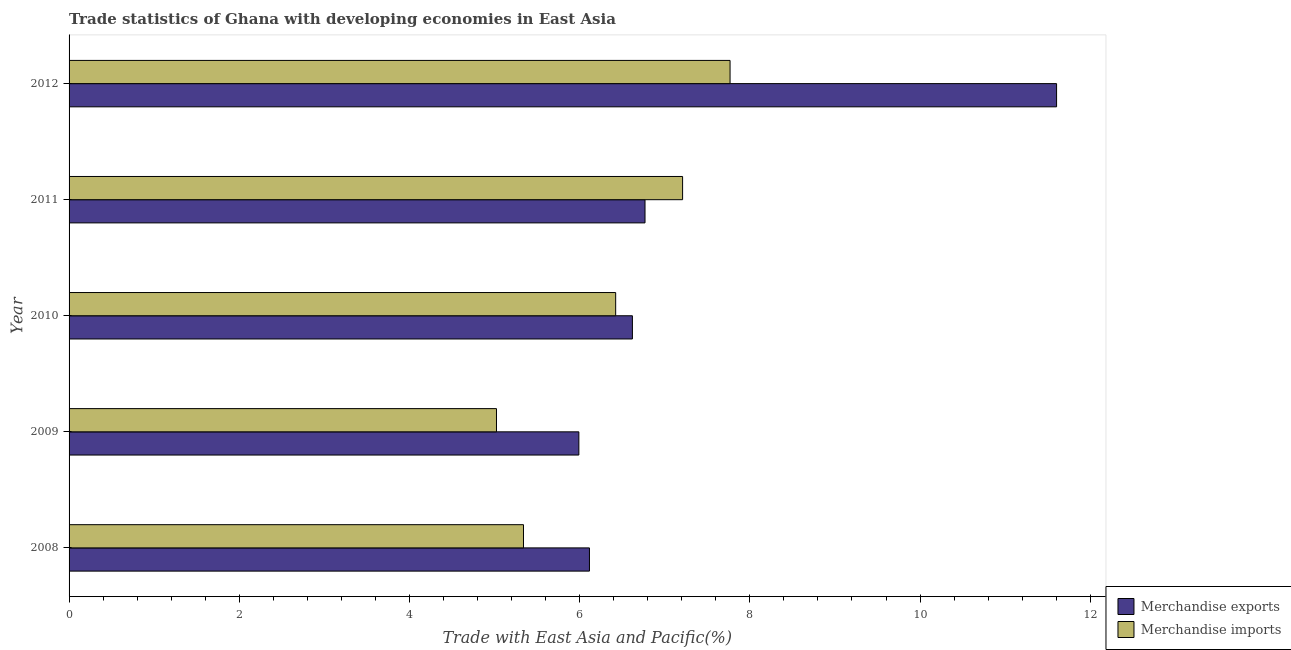How many different coloured bars are there?
Your answer should be very brief. 2. How many groups of bars are there?
Offer a terse response. 5. How many bars are there on the 3rd tick from the top?
Offer a terse response. 2. What is the merchandise exports in 2011?
Give a very brief answer. 6.77. Across all years, what is the maximum merchandise exports?
Make the answer very short. 11.6. Across all years, what is the minimum merchandise exports?
Make the answer very short. 5.99. In which year was the merchandise exports maximum?
Ensure brevity in your answer.  2012. In which year was the merchandise imports minimum?
Provide a succinct answer. 2009. What is the total merchandise imports in the graph?
Provide a short and direct response. 31.76. What is the difference between the merchandise imports in 2009 and that in 2010?
Offer a terse response. -1.4. What is the difference between the merchandise imports in 2010 and the merchandise exports in 2012?
Offer a terse response. -5.18. What is the average merchandise imports per year?
Keep it short and to the point. 6.35. In the year 2012, what is the difference between the merchandise imports and merchandise exports?
Your answer should be compact. -3.84. What is the ratio of the merchandise exports in 2009 to that in 2010?
Offer a terse response. 0.91. Is the merchandise imports in 2008 less than that in 2011?
Ensure brevity in your answer.  Yes. Is the difference between the merchandise exports in 2008 and 2011 greater than the difference between the merchandise imports in 2008 and 2011?
Make the answer very short. Yes. What is the difference between the highest and the second highest merchandise imports?
Your answer should be compact. 0.56. What is the difference between the highest and the lowest merchandise exports?
Ensure brevity in your answer.  5.61. What is the difference between two consecutive major ticks on the X-axis?
Provide a short and direct response. 2. Are the values on the major ticks of X-axis written in scientific E-notation?
Make the answer very short. No. How many legend labels are there?
Your answer should be compact. 2. How are the legend labels stacked?
Keep it short and to the point. Vertical. What is the title of the graph?
Give a very brief answer. Trade statistics of Ghana with developing economies in East Asia. Does "Methane emissions" appear as one of the legend labels in the graph?
Provide a short and direct response. No. What is the label or title of the X-axis?
Keep it short and to the point. Trade with East Asia and Pacific(%). What is the label or title of the Y-axis?
Keep it short and to the point. Year. What is the Trade with East Asia and Pacific(%) of Merchandise exports in 2008?
Offer a very short reply. 6.12. What is the Trade with East Asia and Pacific(%) in Merchandise imports in 2008?
Keep it short and to the point. 5.34. What is the Trade with East Asia and Pacific(%) of Merchandise exports in 2009?
Keep it short and to the point. 5.99. What is the Trade with East Asia and Pacific(%) of Merchandise imports in 2009?
Make the answer very short. 5.02. What is the Trade with East Asia and Pacific(%) of Merchandise exports in 2010?
Your response must be concise. 6.62. What is the Trade with East Asia and Pacific(%) of Merchandise imports in 2010?
Your response must be concise. 6.42. What is the Trade with East Asia and Pacific(%) in Merchandise exports in 2011?
Offer a terse response. 6.77. What is the Trade with East Asia and Pacific(%) in Merchandise imports in 2011?
Your answer should be compact. 7.21. What is the Trade with East Asia and Pacific(%) in Merchandise exports in 2012?
Offer a very short reply. 11.6. What is the Trade with East Asia and Pacific(%) in Merchandise imports in 2012?
Your answer should be very brief. 7.77. Across all years, what is the maximum Trade with East Asia and Pacific(%) of Merchandise exports?
Give a very brief answer. 11.6. Across all years, what is the maximum Trade with East Asia and Pacific(%) in Merchandise imports?
Make the answer very short. 7.77. Across all years, what is the minimum Trade with East Asia and Pacific(%) in Merchandise exports?
Offer a terse response. 5.99. Across all years, what is the minimum Trade with East Asia and Pacific(%) of Merchandise imports?
Provide a succinct answer. 5.02. What is the total Trade with East Asia and Pacific(%) of Merchandise exports in the graph?
Offer a terse response. 37.1. What is the total Trade with East Asia and Pacific(%) in Merchandise imports in the graph?
Provide a succinct answer. 31.76. What is the difference between the Trade with East Asia and Pacific(%) of Merchandise exports in 2008 and that in 2009?
Ensure brevity in your answer.  0.12. What is the difference between the Trade with East Asia and Pacific(%) of Merchandise imports in 2008 and that in 2009?
Your answer should be compact. 0.32. What is the difference between the Trade with East Asia and Pacific(%) in Merchandise exports in 2008 and that in 2010?
Offer a terse response. -0.5. What is the difference between the Trade with East Asia and Pacific(%) in Merchandise imports in 2008 and that in 2010?
Provide a succinct answer. -1.08. What is the difference between the Trade with East Asia and Pacific(%) of Merchandise exports in 2008 and that in 2011?
Give a very brief answer. -0.65. What is the difference between the Trade with East Asia and Pacific(%) of Merchandise imports in 2008 and that in 2011?
Offer a terse response. -1.87. What is the difference between the Trade with East Asia and Pacific(%) of Merchandise exports in 2008 and that in 2012?
Your response must be concise. -5.49. What is the difference between the Trade with East Asia and Pacific(%) in Merchandise imports in 2008 and that in 2012?
Make the answer very short. -2.43. What is the difference between the Trade with East Asia and Pacific(%) of Merchandise exports in 2009 and that in 2010?
Keep it short and to the point. -0.63. What is the difference between the Trade with East Asia and Pacific(%) of Merchandise imports in 2009 and that in 2010?
Ensure brevity in your answer.  -1.4. What is the difference between the Trade with East Asia and Pacific(%) of Merchandise exports in 2009 and that in 2011?
Provide a succinct answer. -0.78. What is the difference between the Trade with East Asia and Pacific(%) of Merchandise imports in 2009 and that in 2011?
Provide a succinct answer. -2.19. What is the difference between the Trade with East Asia and Pacific(%) of Merchandise exports in 2009 and that in 2012?
Provide a short and direct response. -5.61. What is the difference between the Trade with East Asia and Pacific(%) in Merchandise imports in 2009 and that in 2012?
Ensure brevity in your answer.  -2.74. What is the difference between the Trade with East Asia and Pacific(%) in Merchandise exports in 2010 and that in 2011?
Ensure brevity in your answer.  -0.15. What is the difference between the Trade with East Asia and Pacific(%) in Merchandise imports in 2010 and that in 2011?
Ensure brevity in your answer.  -0.79. What is the difference between the Trade with East Asia and Pacific(%) of Merchandise exports in 2010 and that in 2012?
Your answer should be very brief. -4.98. What is the difference between the Trade with East Asia and Pacific(%) in Merchandise imports in 2010 and that in 2012?
Make the answer very short. -1.34. What is the difference between the Trade with East Asia and Pacific(%) in Merchandise exports in 2011 and that in 2012?
Offer a very short reply. -4.84. What is the difference between the Trade with East Asia and Pacific(%) of Merchandise imports in 2011 and that in 2012?
Ensure brevity in your answer.  -0.56. What is the difference between the Trade with East Asia and Pacific(%) of Merchandise exports in 2008 and the Trade with East Asia and Pacific(%) of Merchandise imports in 2009?
Provide a short and direct response. 1.09. What is the difference between the Trade with East Asia and Pacific(%) of Merchandise exports in 2008 and the Trade with East Asia and Pacific(%) of Merchandise imports in 2010?
Your answer should be very brief. -0.31. What is the difference between the Trade with East Asia and Pacific(%) of Merchandise exports in 2008 and the Trade with East Asia and Pacific(%) of Merchandise imports in 2011?
Offer a very short reply. -1.09. What is the difference between the Trade with East Asia and Pacific(%) of Merchandise exports in 2008 and the Trade with East Asia and Pacific(%) of Merchandise imports in 2012?
Make the answer very short. -1.65. What is the difference between the Trade with East Asia and Pacific(%) of Merchandise exports in 2009 and the Trade with East Asia and Pacific(%) of Merchandise imports in 2010?
Offer a terse response. -0.43. What is the difference between the Trade with East Asia and Pacific(%) of Merchandise exports in 2009 and the Trade with East Asia and Pacific(%) of Merchandise imports in 2011?
Offer a terse response. -1.22. What is the difference between the Trade with East Asia and Pacific(%) in Merchandise exports in 2009 and the Trade with East Asia and Pacific(%) in Merchandise imports in 2012?
Your answer should be compact. -1.78. What is the difference between the Trade with East Asia and Pacific(%) in Merchandise exports in 2010 and the Trade with East Asia and Pacific(%) in Merchandise imports in 2011?
Ensure brevity in your answer.  -0.59. What is the difference between the Trade with East Asia and Pacific(%) of Merchandise exports in 2010 and the Trade with East Asia and Pacific(%) of Merchandise imports in 2012?
Offer a very short reply. -1.15. What is the difference between the Trade with East Asia and Pacific(%) of Merchandise exports in 2011 and the Trade with East Asia and Pacific(%) of Merchandise imports in 2012?
Your response must be concise. -1. What is the average Trade with East Asia and Pacific(%) in Merchandise exports per year?
Your answer should be compact. 7.42. What is the average Trade with East Asia and Pacific(%) of Merchandise imports per year?
Offer a very short reply. 6.35. In the year 2008, what is the difference between the Trade with East Asia and Pacific(%) in Merchandise exports and Trade with East Asia and Pacific(%) in Merchandise imports?
Your answer should be very brief. 0.78. In the year 2009, what is the difference between the Trade with East Asia and Pacific(%) in Merchandise exports and Trade with East Asia and Pacific(%) in Merchandise imports?
Ensure brevity in your answer.  0.97. In the year 2010, what is the difference between the Trade with East Asia and Pacific(%) in Merchandise exports and Trade with East Asia and Pacific(%) in Merchandise imports?
Give a very brief answer. 0.2. In the year 2011, what is the difference between the Trade with East Asia and Pacific(%) of Merchandise exports and Trade with East Asia and Pacific(%) of Merchandise imports?
Ensure brevity in your answer.  -0.44. In the year 2012, what is the difference between the Trade with East Asia and Pacific(%) of Merchandise exports and Trade with East Asia and Pacific(%) of Merchandise imports?
Give a very brief answer. 3.84. What is the ratio of the Trade with East Asia and Pacific(%) of Merchandise exports in 2008 to that in 2009?
Your answer should be very brief. 1.02. What is the ratio of the Trade with East Asia and Pacific(%) of Merchandise imports in 2008 to that in 2009?
Make the answer very short. 1.06. What is the ratio of the Trade with East Asia and Pacific(%) in Merchandise exports in 2008 to that in 2010?
Provide a succinct answer. 0.92. What is the ratio of the Trade with East Asia and Pacific(%) in Merchandise imports in 2008 to that in 2010?
Provide a succinct answer. 0.83. What is the ratio of the Trade with East Asia and Pacific(%) in Merchandise exports in 2008 to that in 2011?
Ensure brevity in your answer.  0.9. What is the ratio of the Trade with East Asia and Pacific(%) of Merchandise imports in 2008 to that in 2011?
Give a very brief answer. 0.74. What is the ratio of the Trade with East Asia and Pacific(%) of Merchandise exports in 2008 to that in 2012?
Your answer should be compact. 0.53. What is the ratio of the Trade with East Asia and Pacific(%) of Merchandise imports in 2008 to that in 2012?
Offer a terse response. 0.69. What is the ratio of the Trade with East Asia and Pacific(%) in Merchandise exports in 2009 to that in 2010?
Offer a very short reply. 0.91. What is the ratio of the Trade with East Asia and Pacific(%) in Merchandise imports in 2009 to that in 2010?
Provide a short and direct response. 0.78. What is the ratio of the Trade with East Asia and Pacific(%) in Merchandise exports in 2009 to that in 2011?
Your answer should be compact. 0.89. What is the ratio of the Trade with East Asia and Pacific(%) of Merchandise imports in 2009 to that in 2011?
Provide a succinct answer. 0.7. What is the ratio of the Trade with East Asia and Pacific(%) of Merchandise exports in 2009 to that in 2012?
Your response must be concise. 0.52. What is the ratio of the Trade with East Asia and Pacific(%) in Merchandise imports in 2009 to that in 2012?
Your answer should be very brief. 0.65. What is the ratio of the Trade with East Asia and Pacific(%) of Merchandise exports in 2010 to that in 2011?
Offer a very short reply. 0.98. What is the ratio of the Trade with East Asia and Pacific(%) of Merchandise imports in 2010 to that in 2011?
Your answer should be compact. 0.89. What is the ratio of the Trade with East Asia and Pacific(%) in Merchandise exports in 2010 to that in 2012?
Your response must be concise. 0.57. What is the ratio of the Trade with East Asia and Pacific(%) in Merchandise imports in 2010 to that in 2012?
Keep it short and to the point. 0.83. What is the ratio of the Trade with East Asia and Pacific(%) in Merchandise exports in 2011 to that in 2012?
Make the answer very short. 0.58. What is the ratio of the Trade with East Asia and Pacific(%) in Merchandise imports in 2011 to that in 2012?
Provide a succinct answer. 0.93. What is the difference between the highest and the second highest Trade with East Asia and Pacific(%) in Merchandise exports?
Offer a very short reply. 4.84. What is the difference between the highest and the second highest Trade with East Asia and Pacific(%) of Merchandise imports?
Your answer should be compact. 0.56. What is the difference between the highest and the lowest Trade with East Asia and Pacific(%) in Merchandise exports?
Your answer should be compact. 5.61. What is the difference between the highest and the lowest Trade with East Asia and Pacific(%) in Merchandise imports?
Your answer should be very brief. 2.74. 